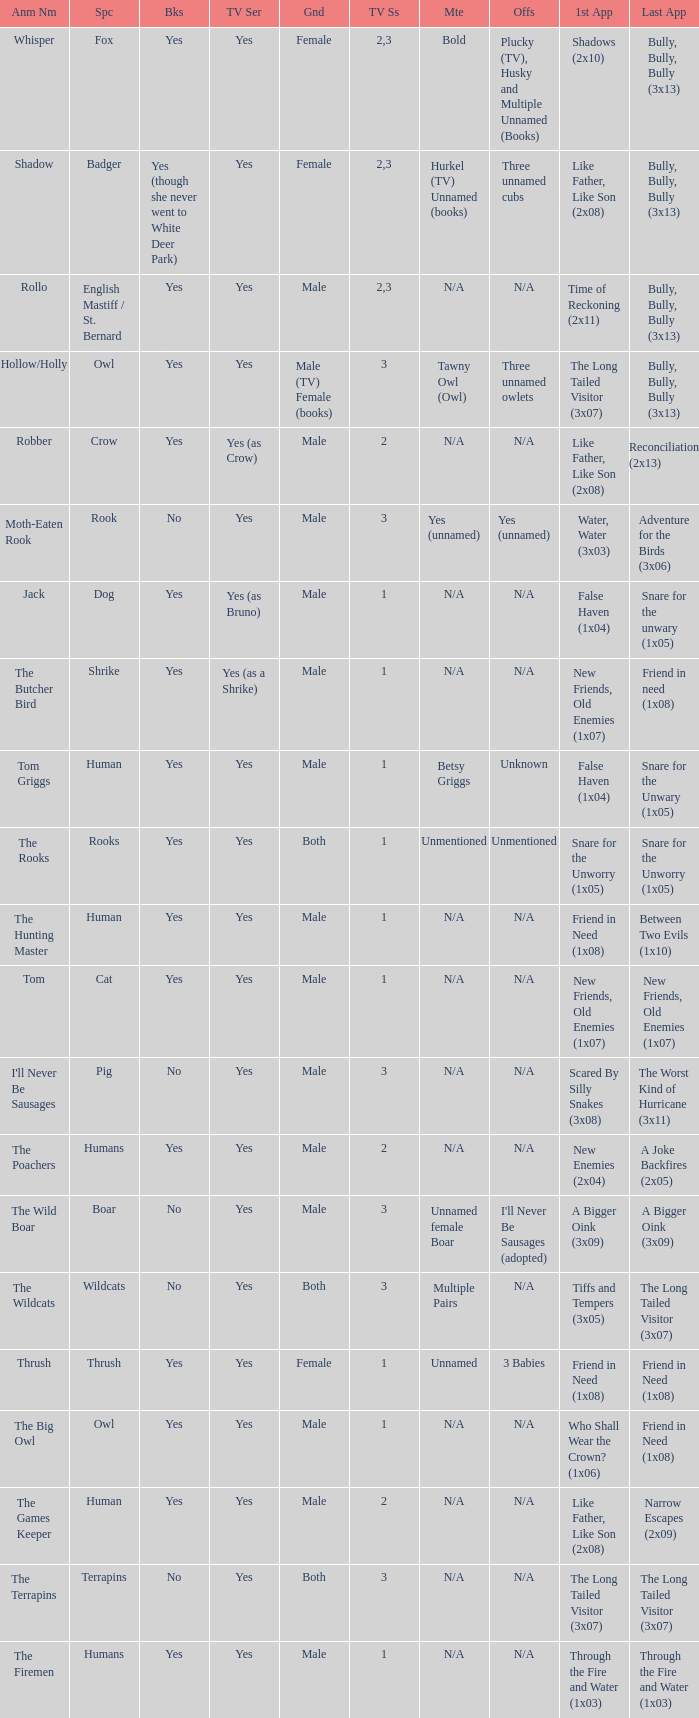What show has a boar? Yes. 